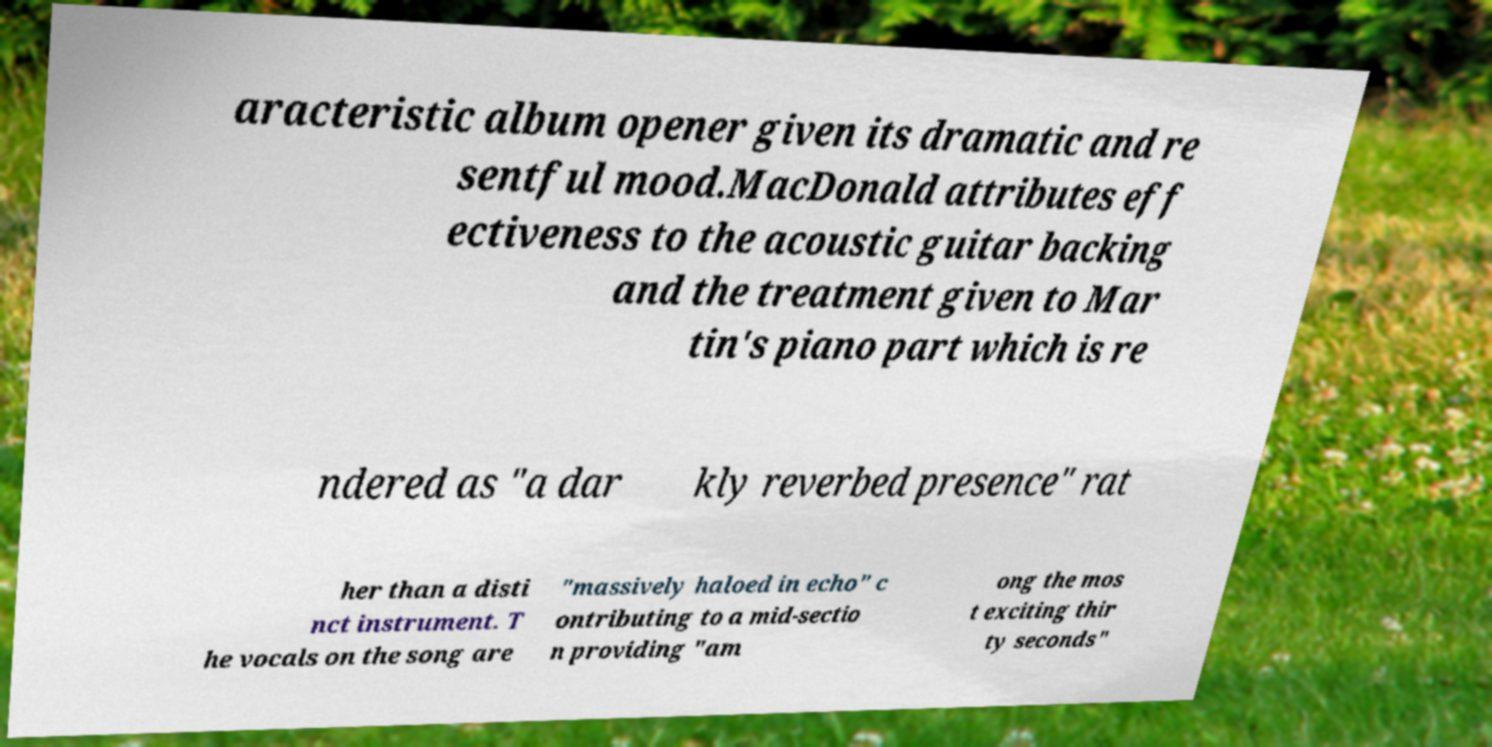Please identify and transcribe the text found in this image. aracteristic album opener given its dramatic and re sentful mood.MacDonald attributes eff ectiveness to the acoustic guitar backing and the treatment given to Mar tin's piano part which is re ndered as "a dar kly reverbed presence" rat her than a disti nct instrument. T he vocals on the song are "massively haloed in echo" c ontributing to a mid-sectio n providing "am ong the mos t exciting thir ty seconds" 